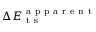Convert formula to latex. <formula><loc_0><loc_0><loc_500><loc_500>\Delta E _ { t s } ^ { a p p a r e n t }</formula> 